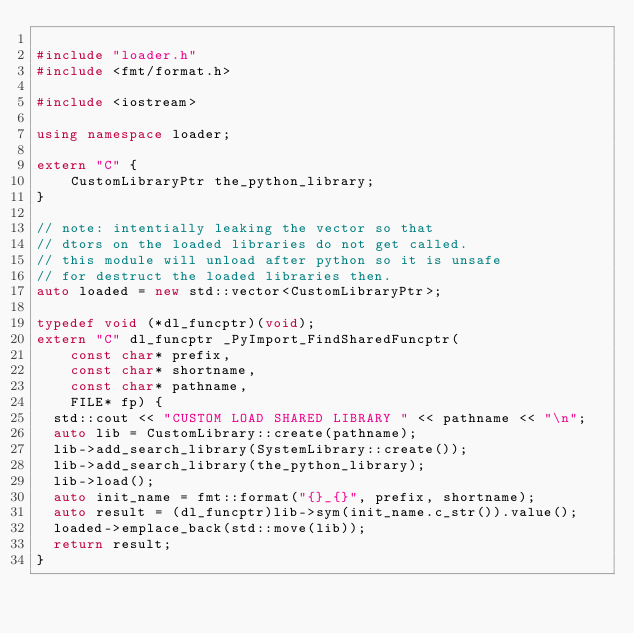Convert code to text. <code><loc_0><loc_0><loc_500><loc_500><_C++_>
#include "loader.h"
#include <fmt/format.h>

#include <iostream>

using namespace loader;

extern "C" {
    CustomLibraryPtr the_python_library;
}

// note: intentially leaking the vector so that
// dtors on the loaded libraries do not get called.
// this module will unload after python so it is unsafe
// for destruct the loaded libraries then.
auto loaded = new std::vector<CustomLibraryPtr>;

typedef void (*dl_funcptr)(void);
extern "C" dl_funcptr _PyImport_FindSharedFuncptr(
    const char* prefix,
    const char* shortname,
    const char* pathname,
    FILE* fp) {
  std::cout << "CUSTOM LOAD SHARED LIBRARY " << pathname << "\n";
  auto lib = CustomLibrary::create(pathname);
  lib->add_search_library(SystemLibrary::create());
  lib->add_search_library(the_python_library);
  lib->load();
  auto init_name = fmt::format("{}_{}", prefix, shortname);
  auto result = (dl_funcptr)lib->sym(init_name.c_str()).value();
  loaded->emplace_back(std::move(lib));
  return result;
}</code> 